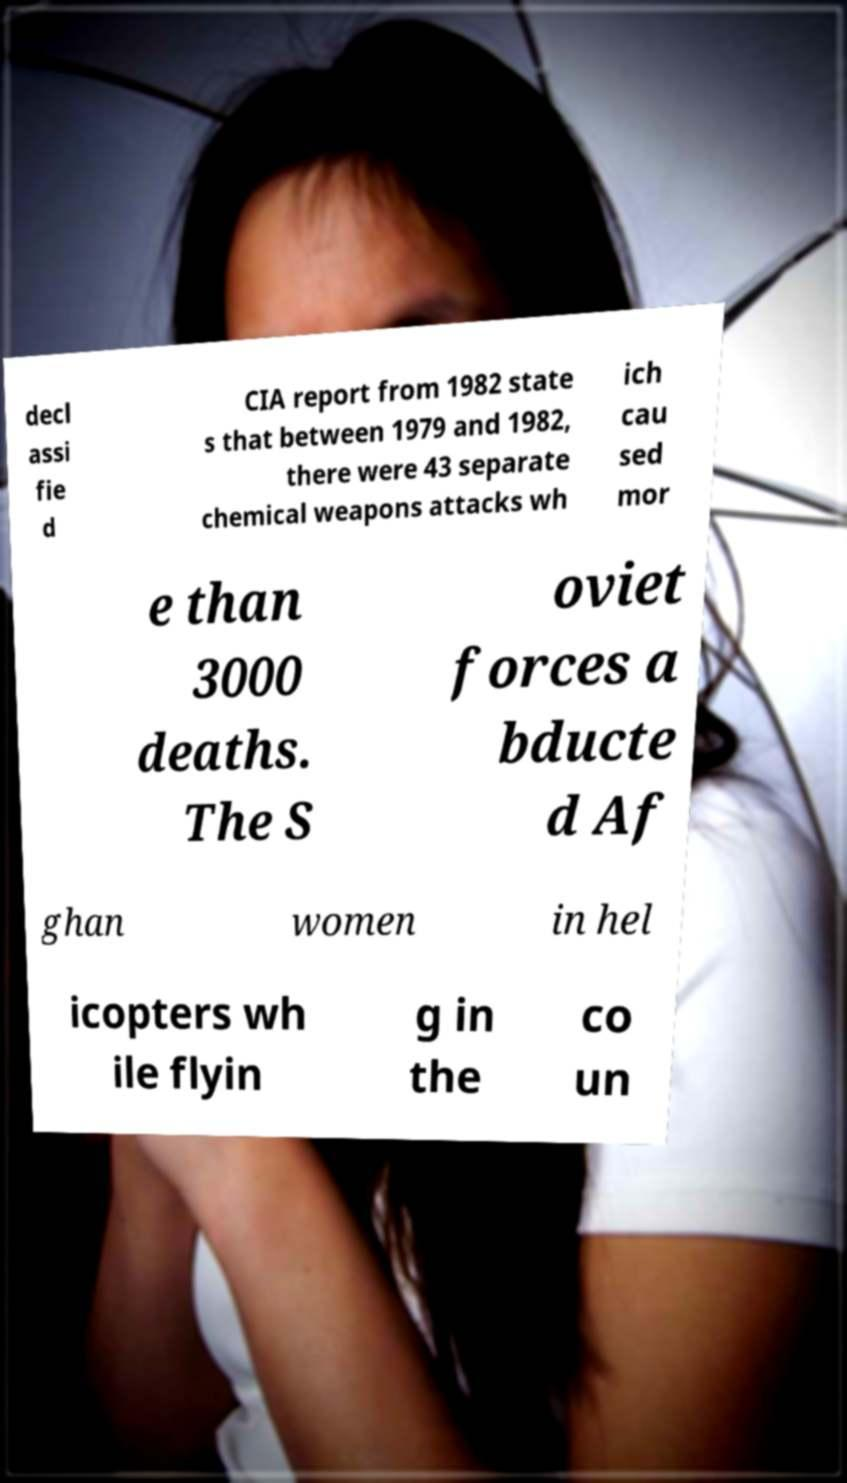I need the written content from this picture converted into text. Can you do that? decl assi fie d CIA report from 1982 state s that between 1979 and 1982, there were 43 separate chemical weapons attacks wh ich cau sed mor e than 3000 deaths. The S oviet forces a bducte d Af ghan women in hel icopters wh ile flyin g in the co un 